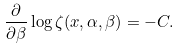<formula> <loc_0><loc_0><loc_500><loc_500>\frac { \partial } { \partial \beta } \log \zeta ( x , \alpha , \beta ) = - C .</formula> 